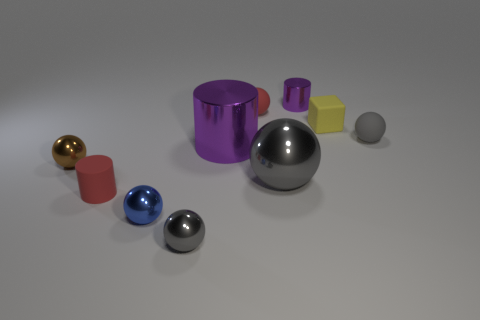There is a thing that is the same color as the tiny shiny cylinder; what is its size? The large, purple cylinder shares its color with the smaller shiny one. Given the smaller one's size and the size of surrounding objects, the larger cylinder could be considered to be of medium size in comparison to everyday objects like furniture yet much larger in relation to the tiny cylinder. 